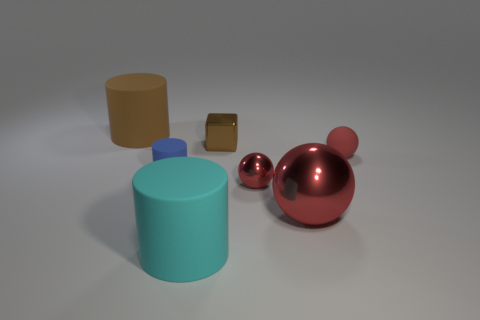Can you tell me the colors of the objects in the image? Certainly! From left to right, there is a tall cylinder that is beige, a smaller cube that appears to be gold or bronze, a small sphere that is blue, and a larger, shinier sphere with a smaller ball attached on top—both in a cherry red color. 